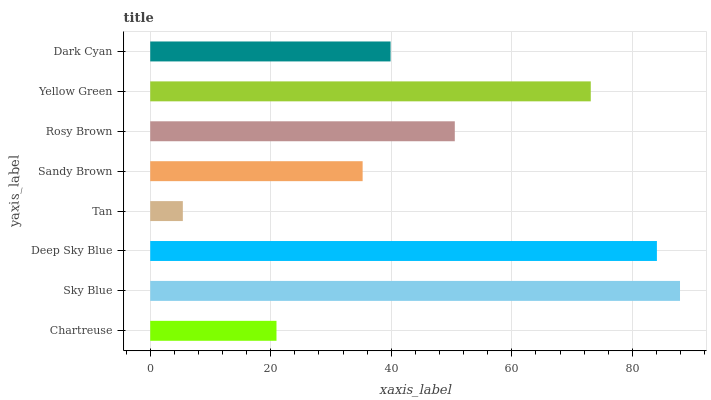Is Tan the minimum?
Answer yes or no. Yes. Is Sky Blue the maximum?
Answer yes or no. Yes. Is Deep Sky Blue the minimum?
Answer yes or no. No. Is Deep Sky Blue the maximum?
Answer yes or no. No. Is Sky Blue greater than Deep Sky Blue?
Answer yes or no. Yes. Is Deep Sky Blue less than Sky Blue?
Answer yes or no. Yes. Is Deep Sky Blue greater than Sky Blue?
Answer yes or no. No. Is Sky Blue less than Deep Sky Blue?
Answer yes or no. No. Is Rosy Brown the high median?
Answer yes or no. Yes. Is Dark Cyan the low median?
Answer yes or no. Yes. Is Sky Blue the high median?
Answer yes or no. No. Is Chartreuse the low median?
Answer yes or no. No. 